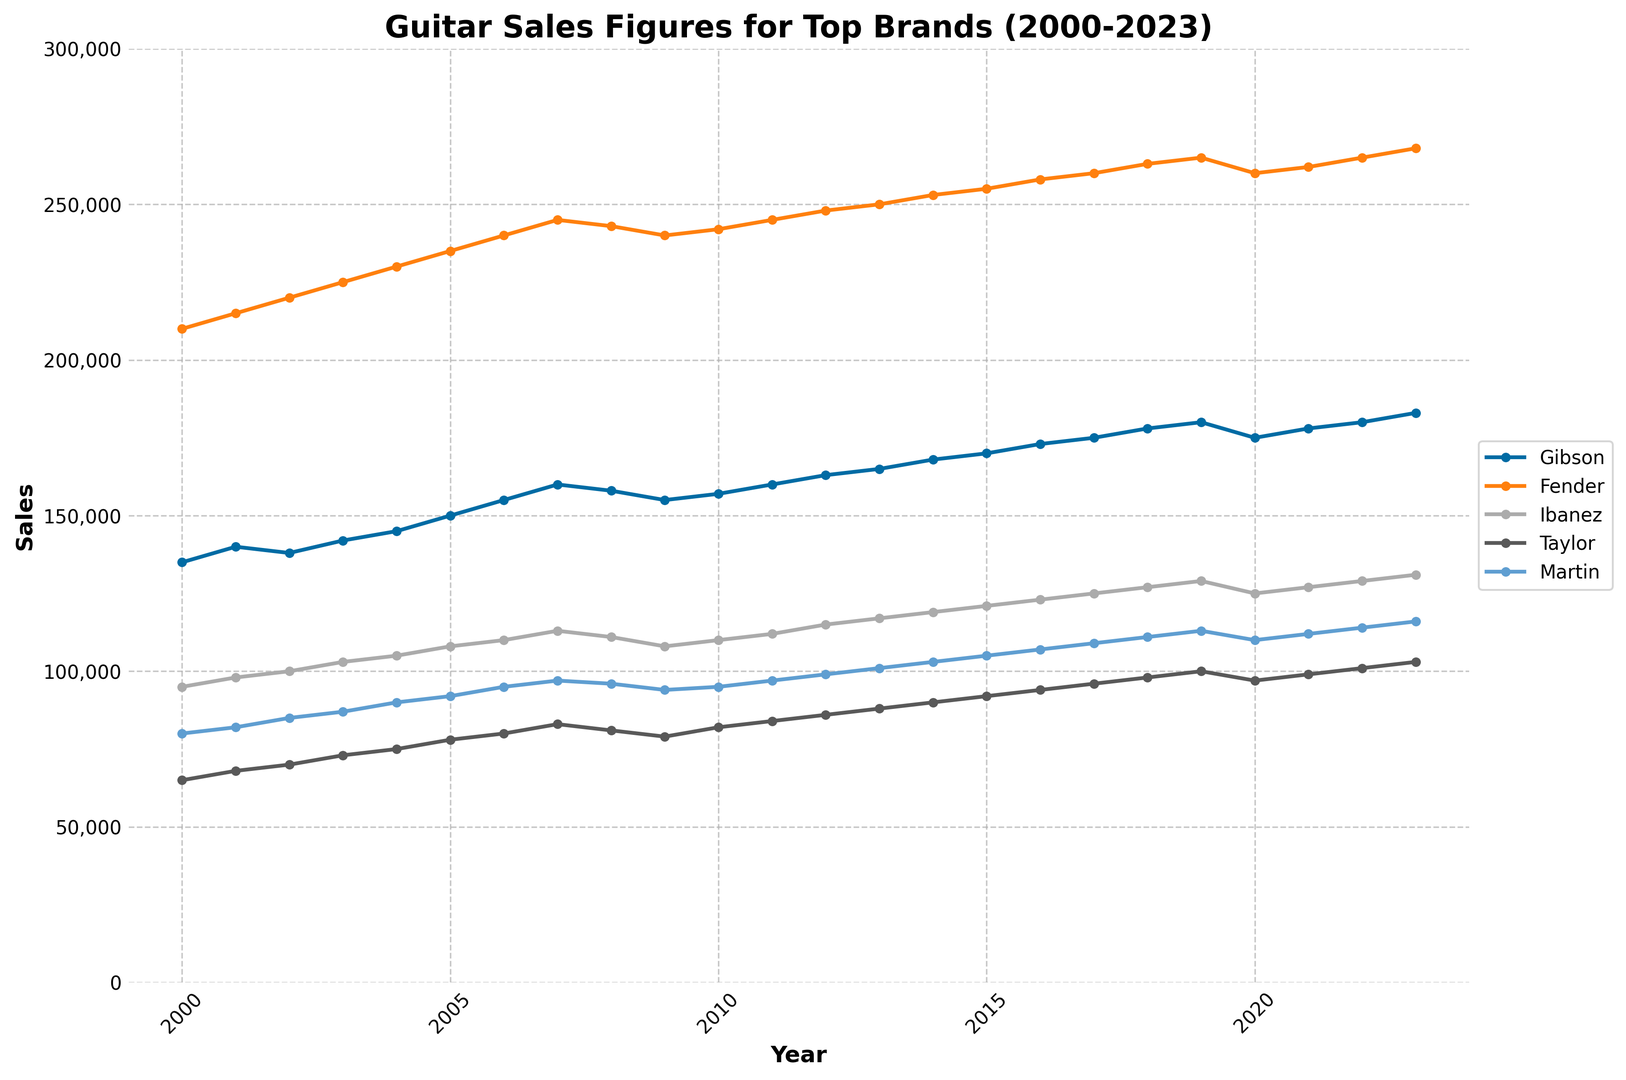What's the overall trend for Fender's sales figures from 2000 to 2023? Observing the line representing Fender, it generally increases from 210,000 in 2000 to 268,000 in 2023, indicating a consistent upward trend with slight fluctuations.
Answer: Increasing trend Which brand had the highest sales in 2023? To determine the highest sales in 2023, compare the endpoints of the lines. Fender reached 268,000, which is the highest among all brands.
Answer: Fender In which year did Gibson and Taylor's sales both increase compared to the previous year? Checking Gibson and Taylor's line trends, both increased in 2001 compared to 2000. Gibson went from 135,000 to 140,000, and Taylor from 65,000 to 68,000.
Answer: 2001 How do the sales figures of Martin in 2004 compare to those in 2023? Observing Martin's line, in 2004 the sales were at 90,000 and in 2023 they increased to 116,000.
Answer: Increased What is the combined sales figure of all the brands in 2015? Sum the sales figures for all brands in 2015: 170,000 (Gibson) + 255,000 (Fender) + 121,000 (Ibanez) + 92,000 (Taylor) + 105,000 (Martin) = 743,000.
Answer: 743,000 Between 2019 and 2020, which brand showed a decline in sales? Comparing the lines for 2019 and 2020, Gibson decreased from 180,000 to 175,000, Fender from 265,000 to 260,000, and Ibanez from 129,000 to 125,000. Thus, these three brands showed a decline.
Answer: Gibson, Fender, Ibanez What’s the average sales figure for Ibanez from 2000 to 2023? Sum up Ibanez's annual sales from 2000 to 2023 and divide by 24 years. (95000+98000+100000+103000+105000+108000+110000+113000+111000+108000+110000+112000+115000+117000+119000+121000+123000+125000+127000+129000+125000+127000+129000+131000) = 2,819,000. Dividing by 24 gives the average sales of 117,458.33.
Answer: 117,458.33 Which brand had the most stable sales figures (least fluctuation) over the years? Visually, the lines for Martin and Ibanez seem less volatile, lacking major spikes or drops. Detailed value comparison confirms Martin has the least year-to-year changes.
Answer: Martin In which year did Fender achieve the highest increase in sales compared to the previous year? Inspecting the year-to-year change for Fender, the highest increase is from 2002 to 2003, where sales rose from 220,000 to 225,000, marking an increase of 5,000.
Answer: 2003 